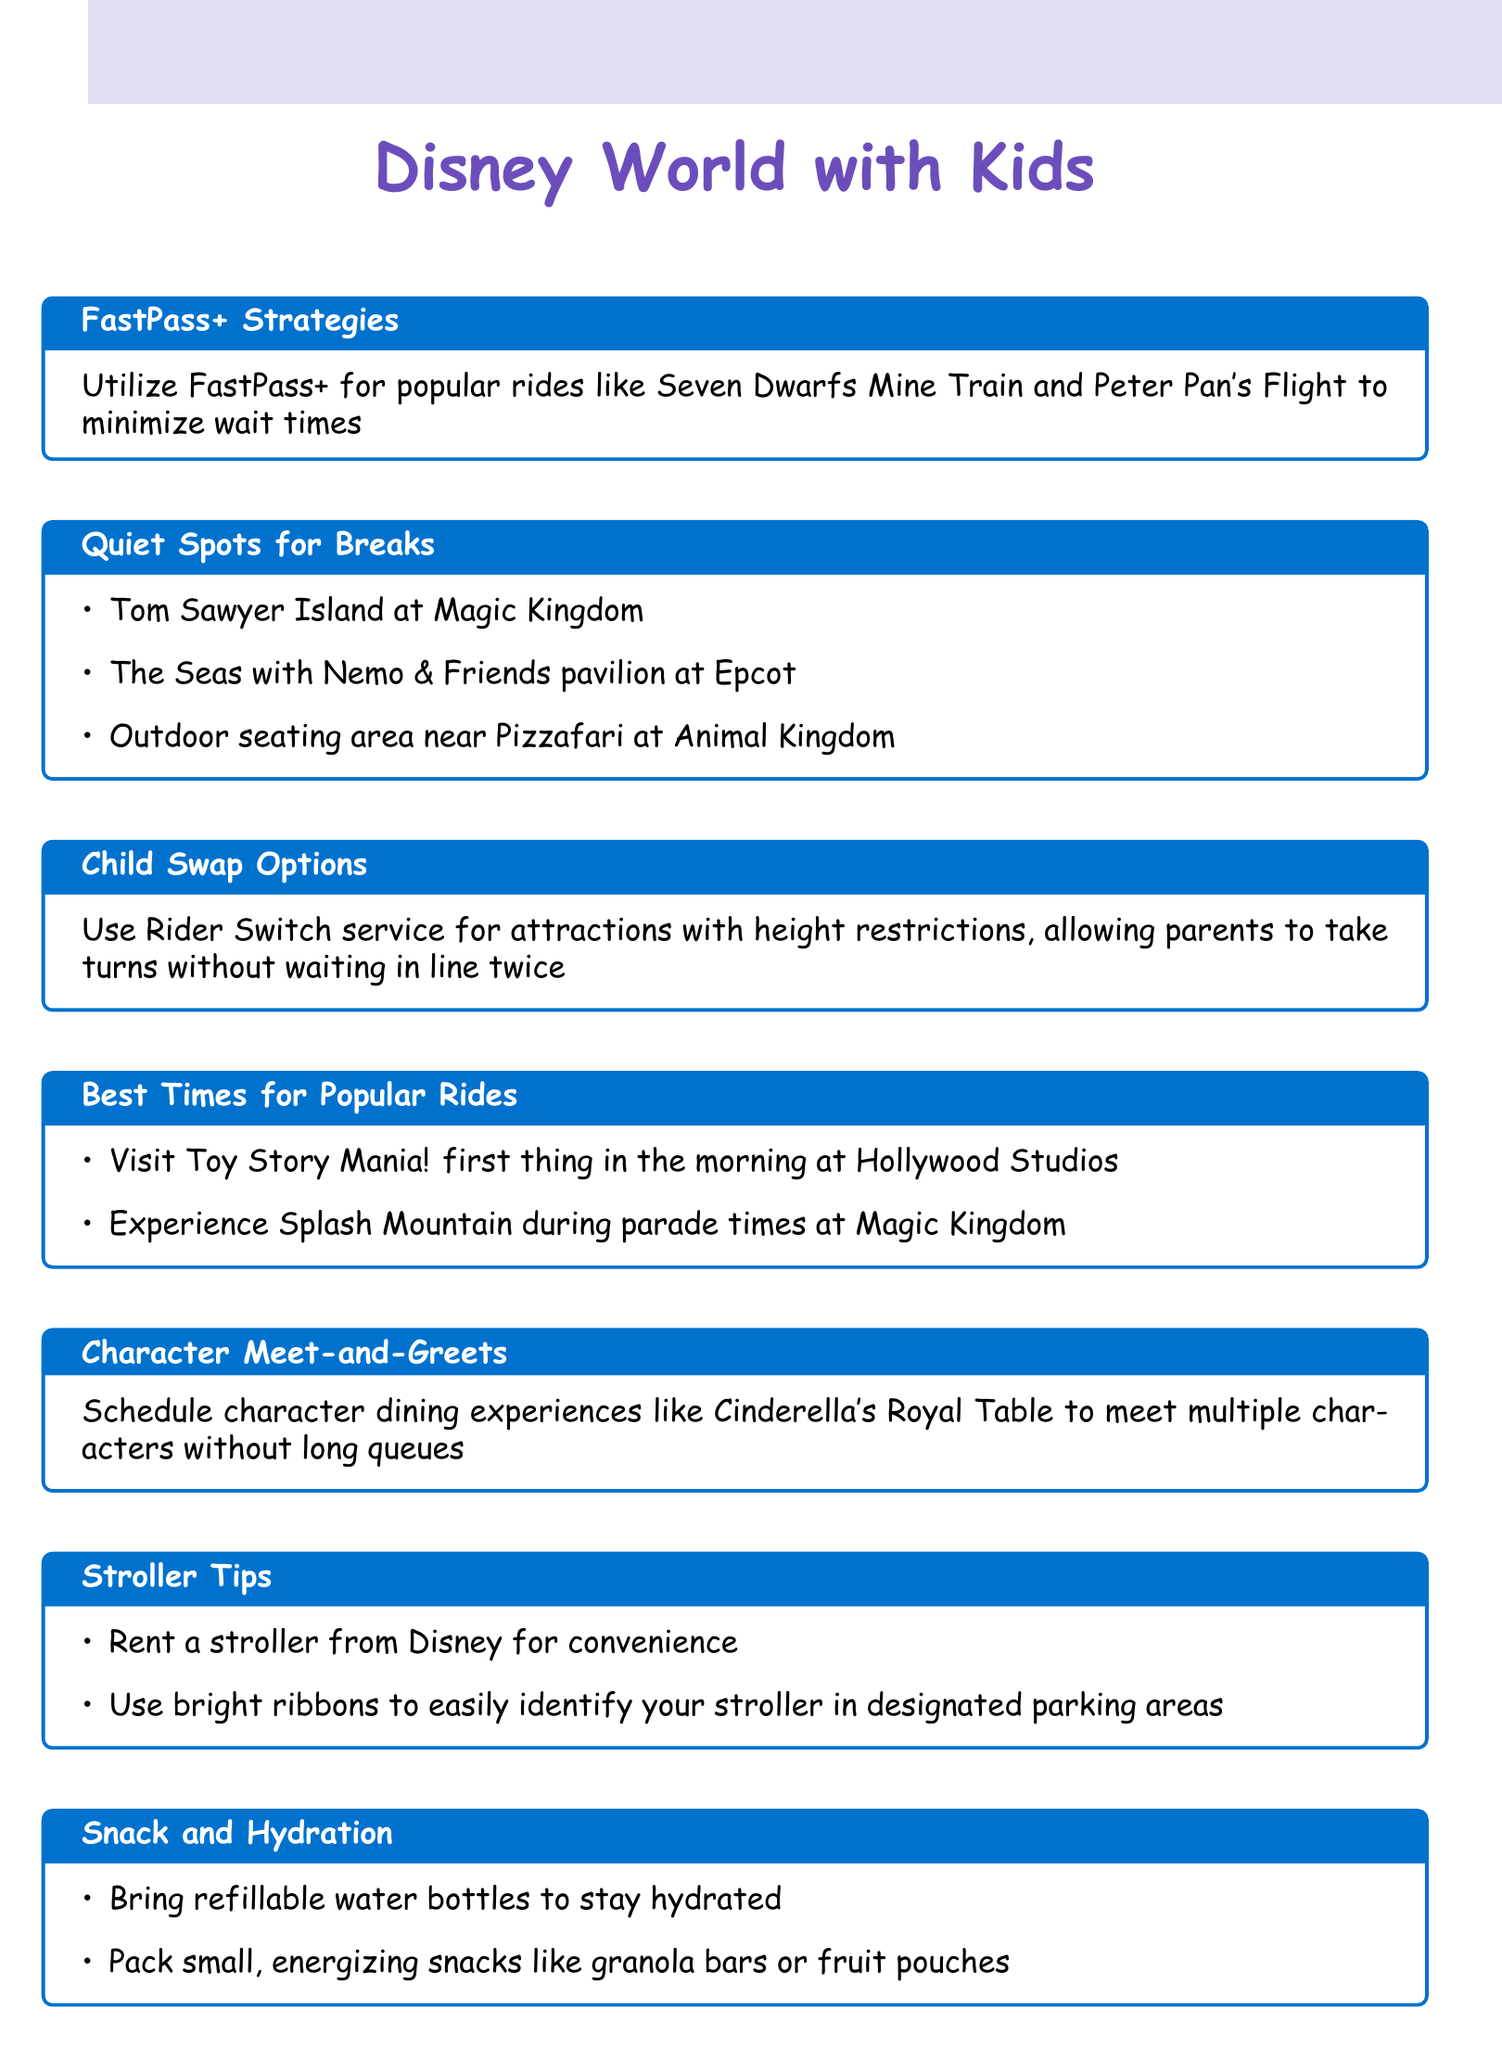What is the title of the section that provides tips for minimizing wait times? The title of the section that focuses on minimizing wait times for rides is FastPass+ Strategies.
Answer: FastPass+ Strategies How many quiet spots for breaks are mentioned? The document lists three specific locations as quiet spots for breaks.
Answer: 3 What service allows parents to take turns for attractions with height restrictions? The service that enables parents to take turns without waiting in line twice for attractions that have height restrictions is Rider Switch.
Answer: Rider Switch Where can you find outdoor seating near Pizzafari? The outdoor seating area near Pizzafari is located at Animal Kingdom, as indicated in the document.
Answer: Animal Kingdom What is suggested for keeping hydrated while at the park? The document recommends bringing refillable water bottles to stay hydrated throughout the park visit.
Answer: Refillable water bottles Which dining experience is recommended for meeting multiple characters? The document suggests scheduling Cinderella's Royal Table for meeting multiple characters efficiently.
Answer: Cinderella's Royal Table What should be used to identify a rented stroller in designated parking areas? To easily identify a rented stroller, the document advises using bright ribbons in designated parking areas.
Answer: Bright ribbons What is the best time to visit Toy Story Mania? According to the document, the best time to visit Toy Story Mania! is first thing in the morning at Hollywood Studios.
Answer: First thing in the morning 